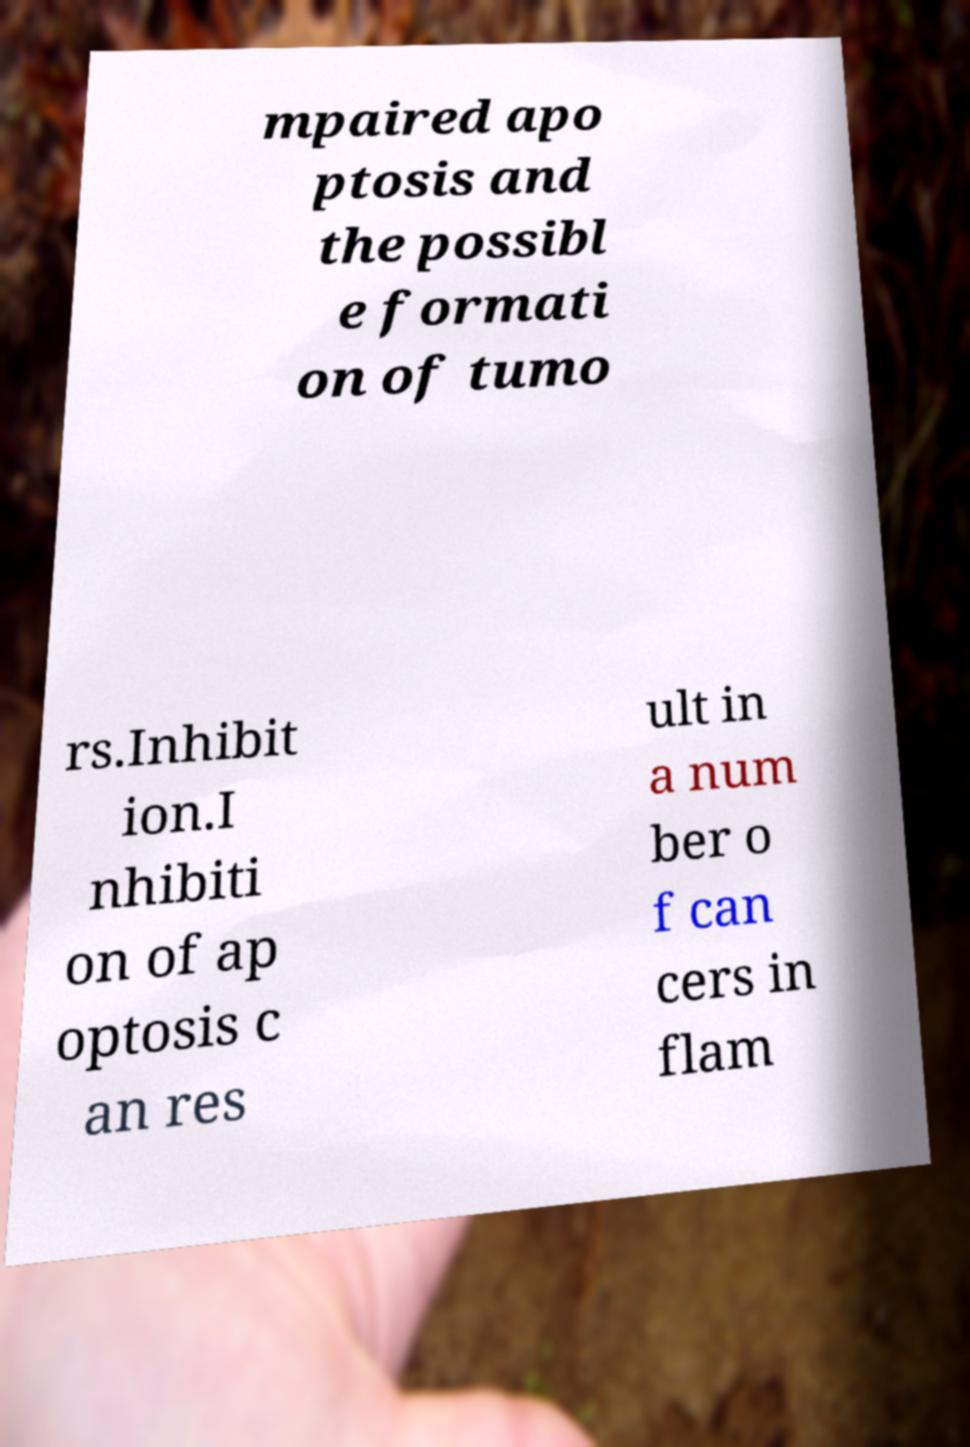Please identify and transcribe the text found in this image. mpaired apo ptosis and the possibl e formati on of tumo rs.Inhibit ion.I nhibiti on of ap optosis c an res ult in a num ber o f can cers in flam 